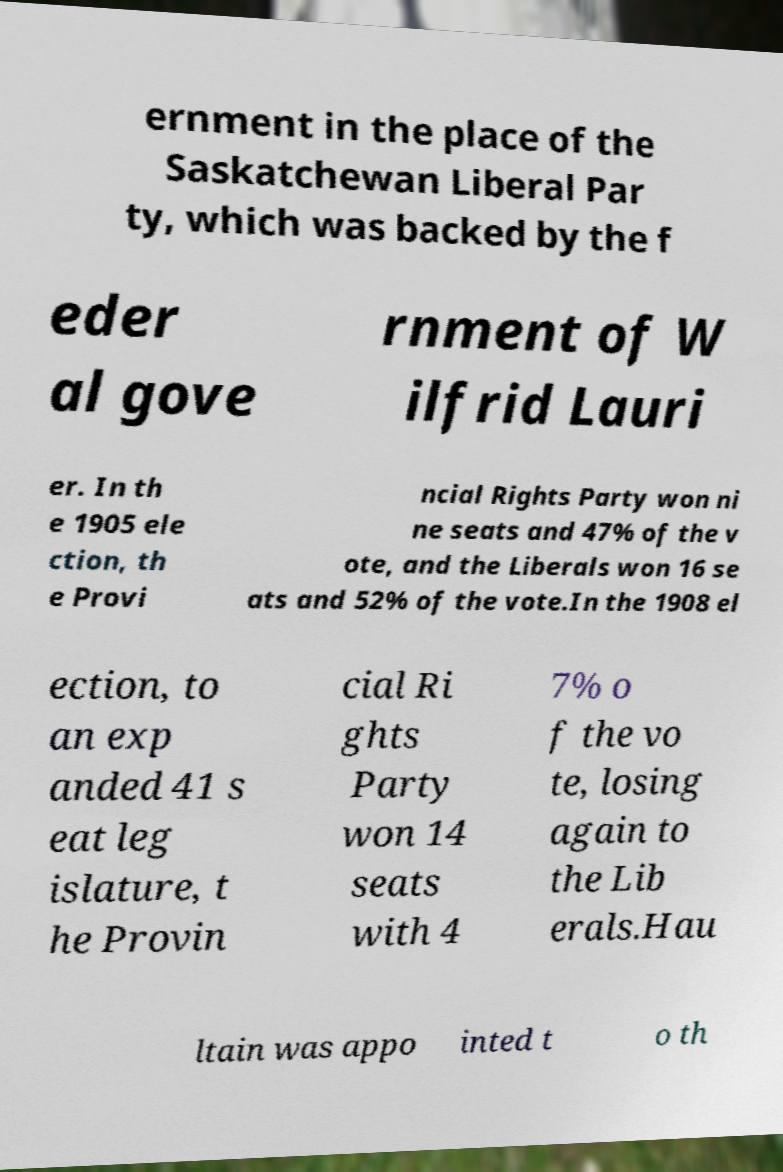For documentation purposes, I need the text within this image transcribed. Could you provide that? ernment in the place of the Saskatchewan Liberal Par ty, which was backed by the f eder al gove rnment of W ilfrid Lauri er. In th e 1905 ele ction, th e Provi ncial Rights Party won ni ne seats and 47% of the v ote, and the Liberals won 16 se ats and 52% of the vote.In the 1908 el ection, to an exp anded 41 s eat leg islature, t he Provin cial Ri ghts Party won 14 seats with 4 7% o f the vo te, losing again to the Lib erals.Hau ltain was appo inted t o th 